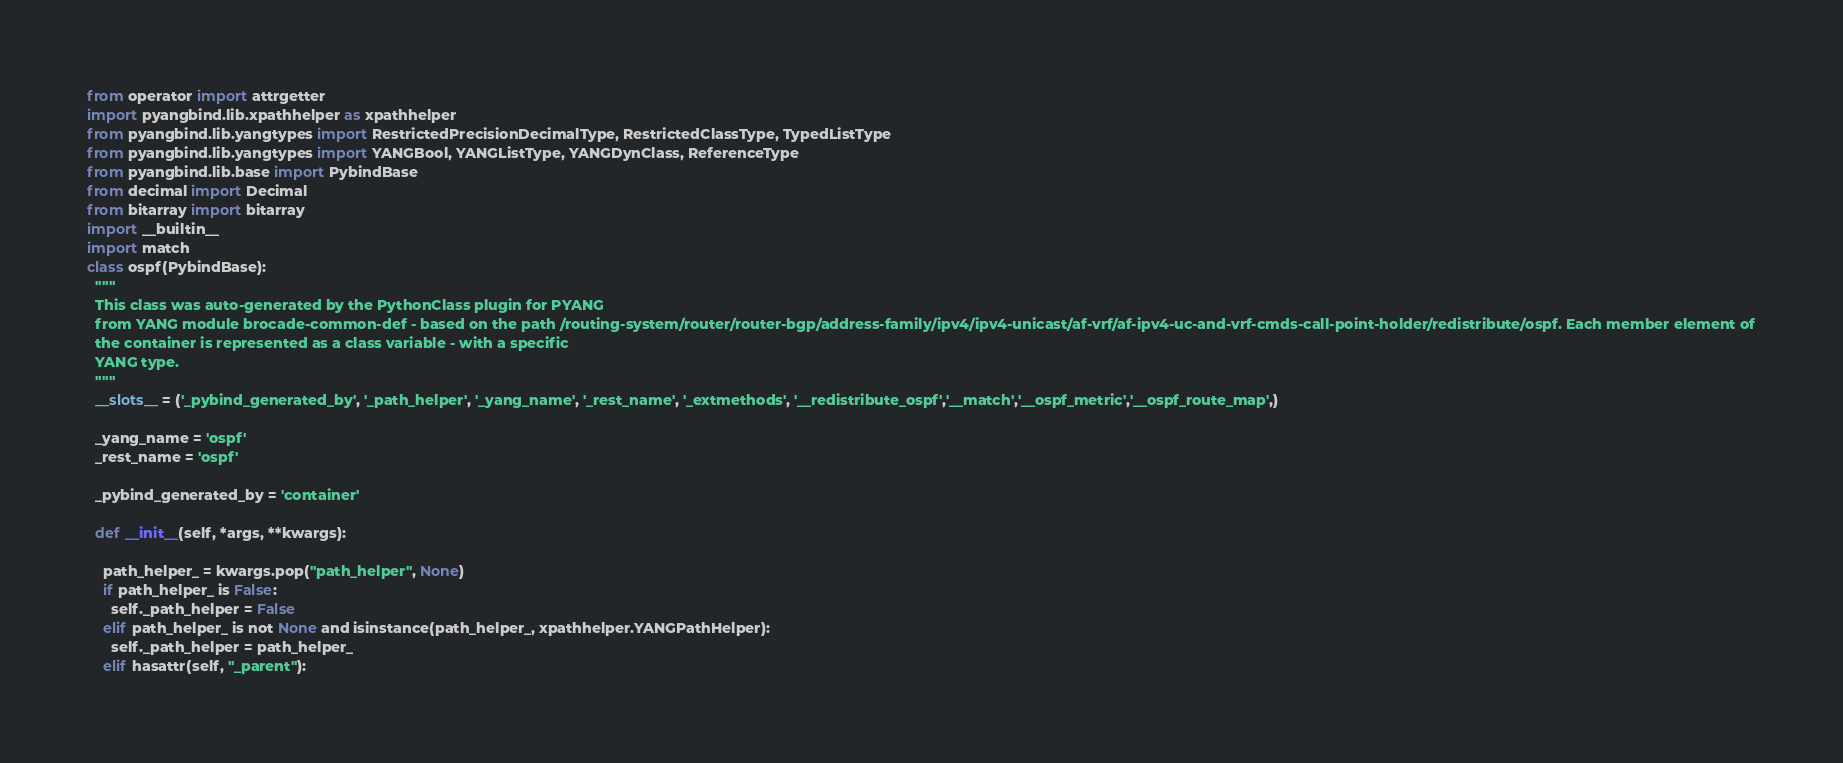Convert code to text. <code><loc_0><loc_0><loc_500><loc_500><_Python_>
from operator import attrgetter
import pyangbind.lib.xpathhelper as xpathhelper
from pyangbind.lib.yangtypes import RestrictedPrecisionDecimalType, RestrictedClassType, TypedListType
from pyangbind.lib.yangtypes import YANGBool, YANGListType, YANGDynClass, ReferenceType
from pyangbind.lib.base import PybindBase
from decimal import Decimal
from bitarray import bitarray
import __builtin__
import match
class ospf(PybindBase):
  """
  This class was auto-generated by the PythonClass plugin for PYANG
  from YANG module brocade-common-def - based on the path /routing-system/router/router-bgp/address-family/ipv4/ipv4-unicast/af-vrf/af-ipv4-uc-and-vrf-cmds-call-point-holder/redistribute/ospf. Each member element of
  the container is represented as a class variable - with a specific
  YANG type.
  """
  __slots__ = ('_pybind_generated_by', '_path_helper', '_yang_name', '_rest_name', '_extmethods', '__redistribute_ospf','__match','__ospf_metric','__ospf_route_map',)

  _yang_name = 'ospf'
  _rest_name = 'ospf'

  _pybind_generated_by = 'container'

  def __init__(self, *args, **kwargs):

    path_helper_ = kwargs.pop("path_helper", None)
    if path_helper_ is False:
      self._path_helper = False
    elif path_helper_ is not None and isinstance(path_helper_, xpathhelper.YANGPathHelper):
      self._path_helper = path_helper_
    elif hasattr(self, "_parent"):</code> 